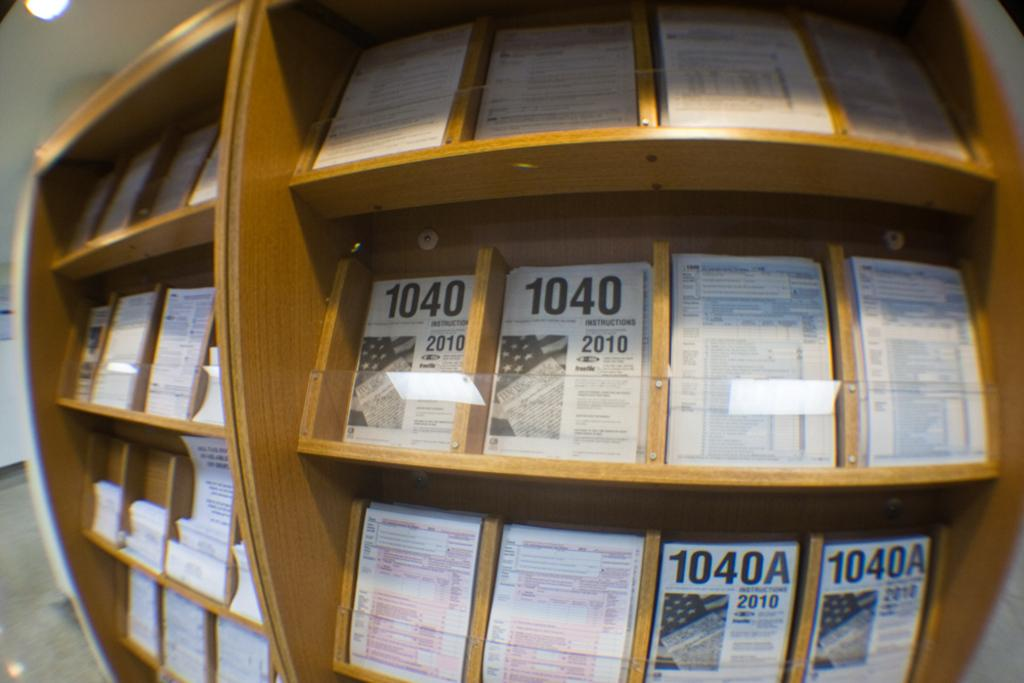<image>
Render a clear and concise summary of the photo. Wooden shelf showing displays including one of a framed paper with the year 2010 on it. 